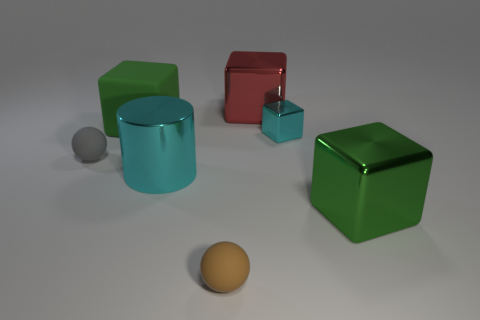Do the large cube that is left of the red block and the sphere to the left of the brown sphere have the same color?
Make the answer very short. No. What material is the red block that is to the right of the green rubber cube that is right of the tiny gray sphere made of?
Keep it short and to the point. Metal. What color is the rubber ball that is the same size as the brown matte object?
Offer a very short reply. Gray. There is a red shiny object; is it the same shape as the large green object behind the cyan cylinder?
Your answer should be compact. Yes. What shape is the tiny metallic thing that is the same color as the shiny cylinder?
Keep it short and to the point. Cube. How many metal things are to the left of the tiny matte sphere that is on the right side of the tiny object on the left side of the small brown object?
Your answer should be very brief. 1. There is a matte ball on the left side of the sphere that is in front of the green metallic object; what size is it?
Your response must be concise. Small. There is a cyan object that is made of the same material as the big cyan cylinder; what size is it?
Provide a short and direct response. Small. What is the shape of the object that is both left of the cyan shiny cube and in front of the big metallic cylinder?
Your answer should be compact. Sphere. Is the number of cylinders that are behind the big red object the same as the number of cyan metal objects?
Offer a terse response. No. 